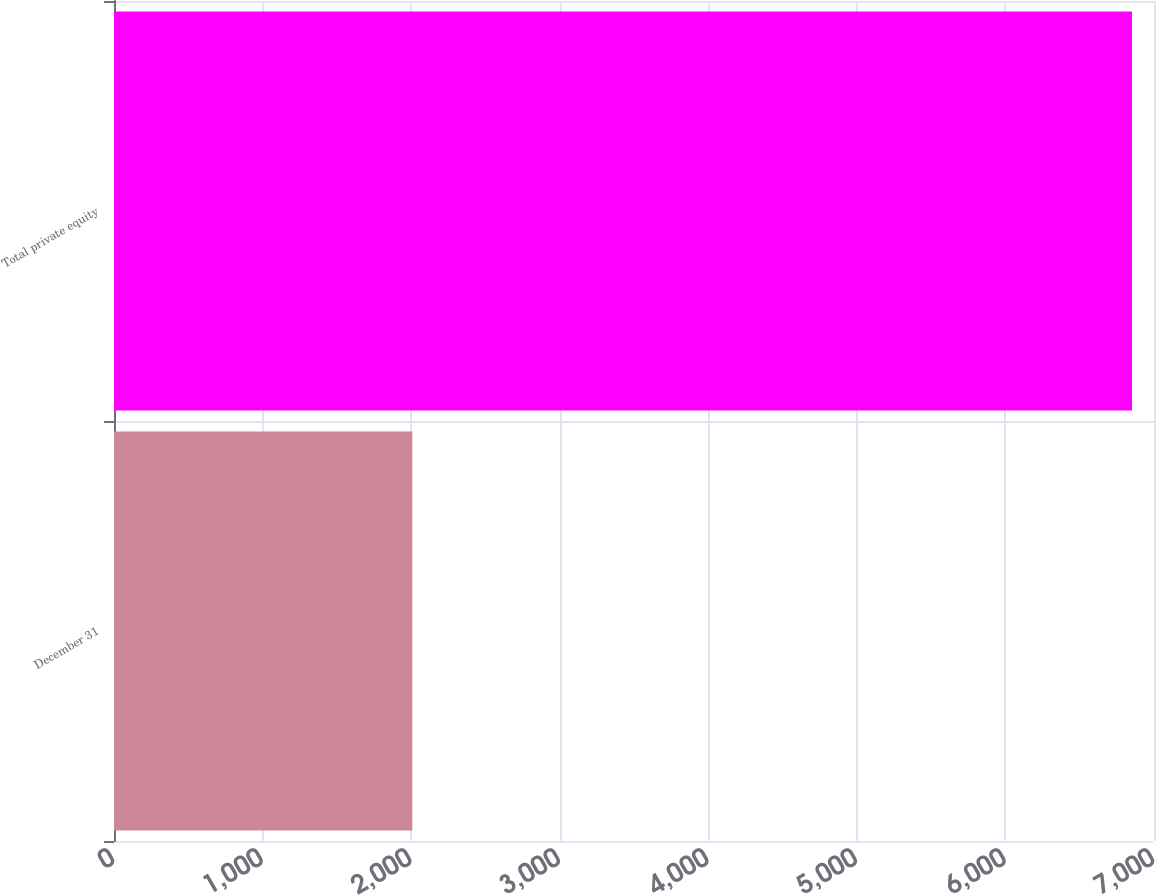Convert chart. <chart><loc_0><loc_0><loc_500><loc_500><bar_chart><fcel>December 31<fcel>Total private equity<nl><fcel>2008<fcel>6852<nl></chart> 